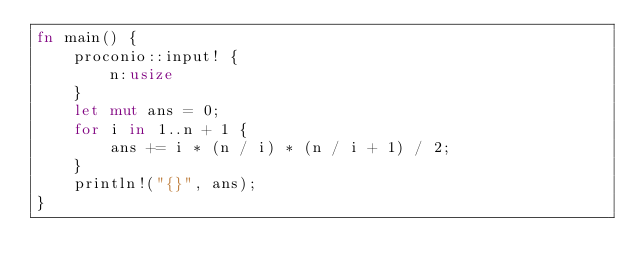<code> <loc_0><loc_0><loc_500><loc_500><_Rust_>fn main() {
    proconio::input! {
        n:usize
    }
    let mut ans = 0;
    for i in 1..n + 1 {
        ans += i * (n / i) * (n / i + 1) / 2;
    }
    println!("{}", ans);
}</code> 